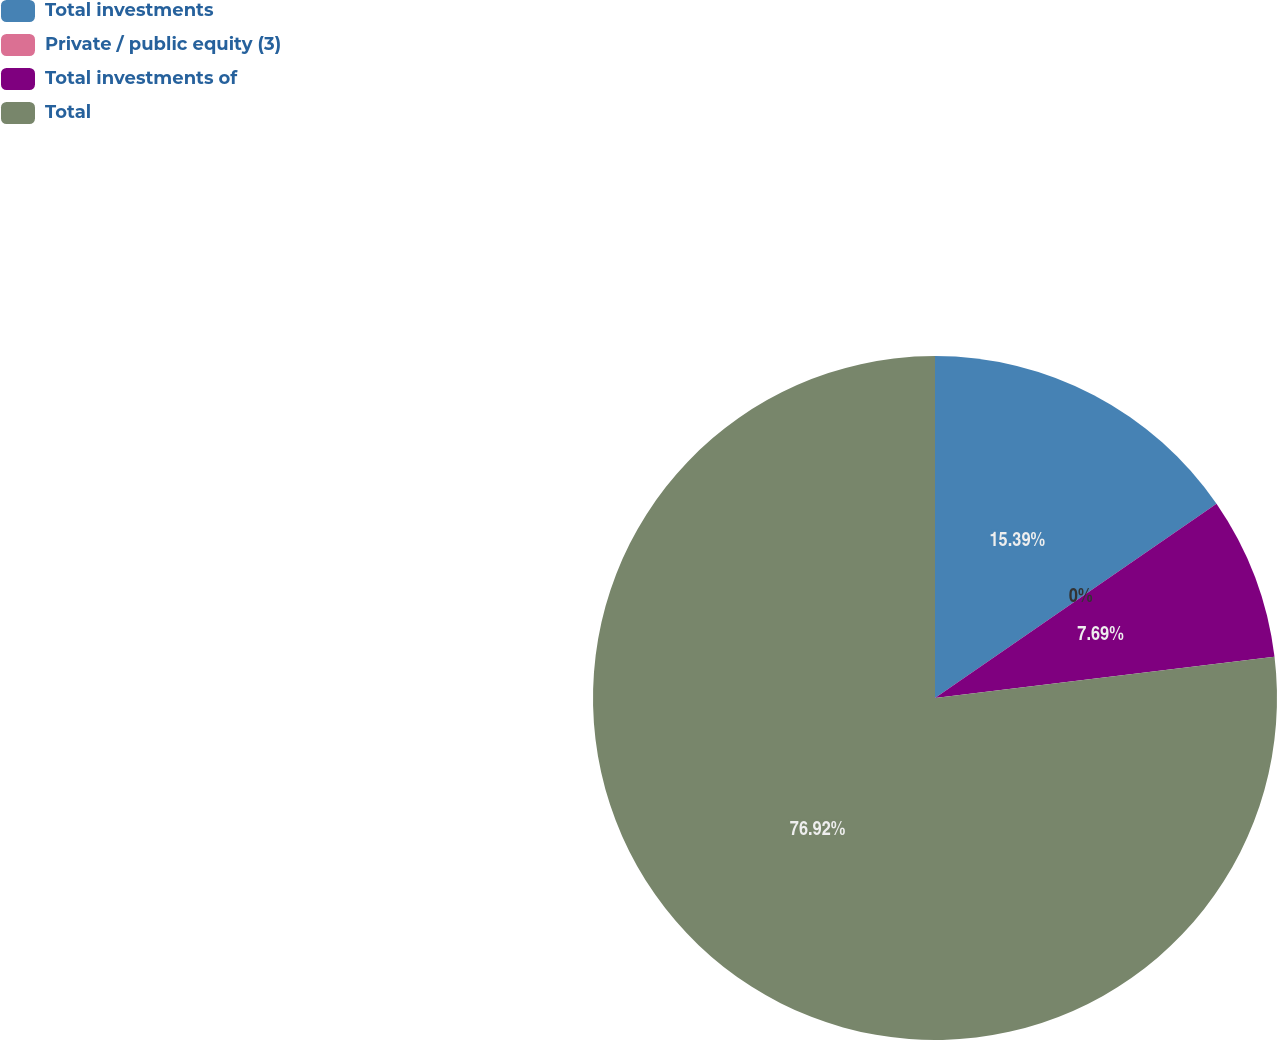Convert chart. <chart><loc_0><loc_0><loc_500><loc_500><pie_chart><fcel>Total investments<fcel>Private / public equity (3)<fcel>Total investments of<fcel>Total<nl><fcel>15.39%<fcel>0.0%<fcel>7.69%<fcel>76.92%<nl></chart> 